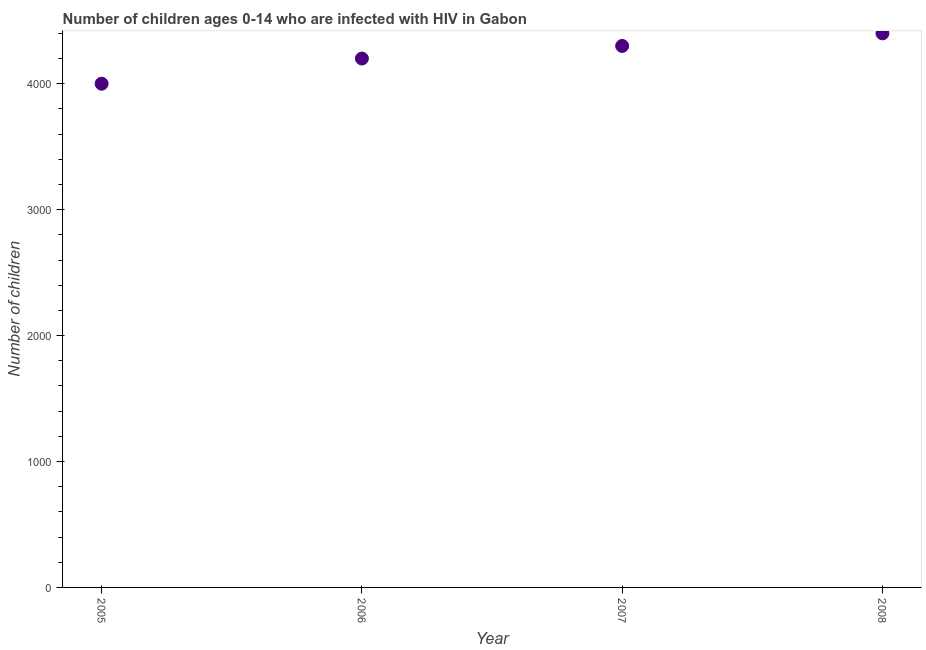What is the number of children living with hiv in 2006?
Provide a succinct answer. 4200. Across all years, what is the maximum number of children living with hiv?
Ensure brevity in your answer.  4400. Across all years, what is the minimum number of children living with hiv?
Provide a succinct answer. 4000. In which year was the number of children living with hiv minimum?
Provide a succinct answer. 2005. What is the sum of the number of children living with hiv?
Ensure brevity in your answer.  1.69e+04. What is the difference between the number of children living with hiv in 2007 and 2008?
Offer a very short reply. -100. What is the average number of children living with hiv per year?
Your response must be concise. 4225. What is the median number of children living with hiv?
Ensure brevity in your answer.  4250. In how many years, is the number of children living with hiv greater than 3000 ?
Your answer should be compact. 4. What is the ratio of the number of children living with hiv in 2005 to that in 2008?
Ensure brevity in your answer.  0.91. Is the difference between the number of children living with hiv in 2006 and 2008 greater than the difference between any two years?
Offer a very short reply. No. What is the difference between the highest and the second highest number of children living with hiv?
Keep it short and to the point. 100. What is the difference between the highest and the lowest number of children living with hiv?
Your answer should be very brief. 400. How many dotlines are there?
Your response must be concise. 1. How many years are there in the graph?
Give a very brief answer. 4. Are the values on the major ticks of Y-axis written in scientific E-notation?
Provide a short and direct response. No. What is the title of the graph?
Make the answer very short. Number of children ages 0-14 who are infected with HIV in Gabon. What is the label or title of the Y-axis?
Your answer should be very brief. Number of children. What is the Number of children in 2005?
Your response must be concise. 4000. What is the Number of children in 2006?
Offer a very short reply. 4200. What is the Number of children in 2007?
Make the answer very short. 4300. What is the Number of children in 2008?
Offer a very short reply. 4400. What is the difference between the Number of children in 2005 and 2006?
Give a very brief answer. -200. What is the difference between the Number of children in 2005 and 2007?
Provide a short and direct response. -300. What is the difference between the Number of children in 2005 and 2008?
Your answer should be very brief. -400. What is the difference between the Number of children in 2006 and 2007?
Keep it short and to the point. -100. What is the difference between the Number of children in 2006 and 2008?
Keep it short and to the point. -200. What is the difference between the Number of children in 2007 and 2008?
Offer a terse response. -100. What is the ratio of the Number of children in 2005 to that in 2006?
Your response must be concise. 0.95. What is the ratio of the Number of children in 2005 to that in 2008?
Ensure brevity in your answer.  0.91. What is the ratio of the Number of children in 2006 to that in 2007?
Provide a succinct answer. 0.98. What is the ratio of the Number of children in 2006 to that in 2008?
Your answer should be compact. 0.95. What is the ratio of the Number of children in 2007 to that in 2008?
Keep it short and to the point. 0.98. 